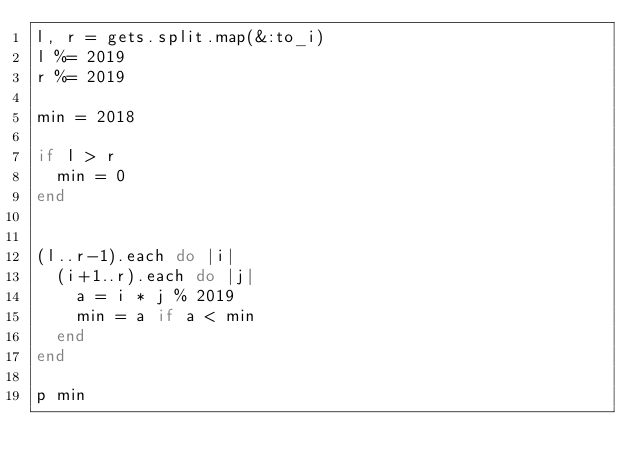Convert code to text. <code><loc_0><loc_0><loc_500><loc_500><_Ruby_>l, r = gets.split.map(&:to_i)
l %= 2019
r %= 2019

min = 2018

if l > r
  min = 0
end


(l..r-1).each do |i|
  (i+1..r).each do |j|
    a = i * j % 2019
    min = a if a < min
  end
end

p min</code> 